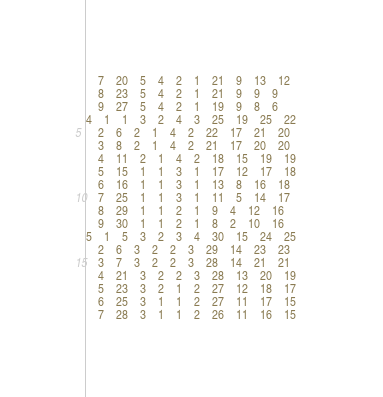<code> <loc_0><loc_0><loc_500><loc_500><_ObjectiveC_>	7	20	5	4	2	1	21	9	13	12	
	8	23	5	4	2	1	21	9	9	9	
	9	27	5	4	2	1	19	9	8	6	
4	1	1	3	2	4	3	25	19	25	22	
	2	6	2	1	4	2	22	17	21	20	
	3	8	2	1	4	2	21	17	20	20	
	4	11	2	1	4	2	18	15	19	19	
	5	15	1	1	3	1	17	12	17	18	
	6	16	1	1	3	1	13	8	16	18	
	7	25	1	1	3	1	11	5	14	17	
	8	29	1	1	2	1	9	4	12	16	
	9	30	1	1	2	1	8	2	10	16	
5	1	5	3	2	3	4	30	15	24	25	
	2	6	3	2	2	3	29	14	23	23	
	3	7	3	2	2	3	28	14	21	21	
	4	21	3	2	2	3	28	13	20	19	
	5	23	3	2	1	2	27	12	18	17	
	6	25	3	1	1	2	27	11	17	15	
	7	28	3	1	1	2	26	11	16	15	</code> 